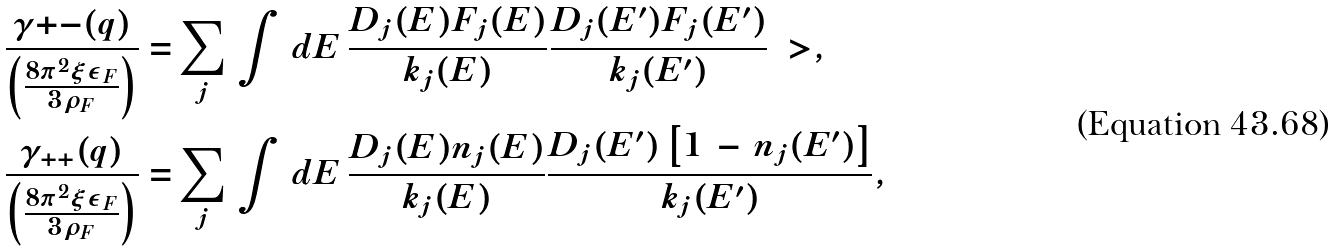Convert formula to latex. <formula><loc_0><loc_0><loc_500><loc_500>\frac { \gamma { + - } ( q ) } { \left ( \frac { 8 \pi ^ { 2 } \xi \epsilon _ { F } } { 3 \rho _ { F } } \right ) } = & \sum _ { j } \, \int \, d E \, \frac { D _ { j } ( E ) F _ { j } ( E ) } { k _ { j } ( E ) } \frac { D _ { j } ( E ^ { \prime } ) F _ { j } ( E ^ { \prime } ) } { k _ { j } ( E ^ { \prime } ) } \ > , \\ \frac { \gamma _ { + + } ( q ) } { \left ( \frac { 8 \pi ^ { 2 } \xi \epsilon _ { F } } { 3 \rho _ { F } } \right ) } = & \sum _ { j } \, \int \, d E \, \frac { D _ { j } ( E ) n _ { j } ( E ) } { k _ { j } ( E ) } \frac { D _ { j } ( E ^ { \prime } ) \left [ 1 \, - \, n _ { j } ( E ^ { \prime } ) \right ] } { k _ { j } ( E ^ { \prime } ) } ,</formula> 